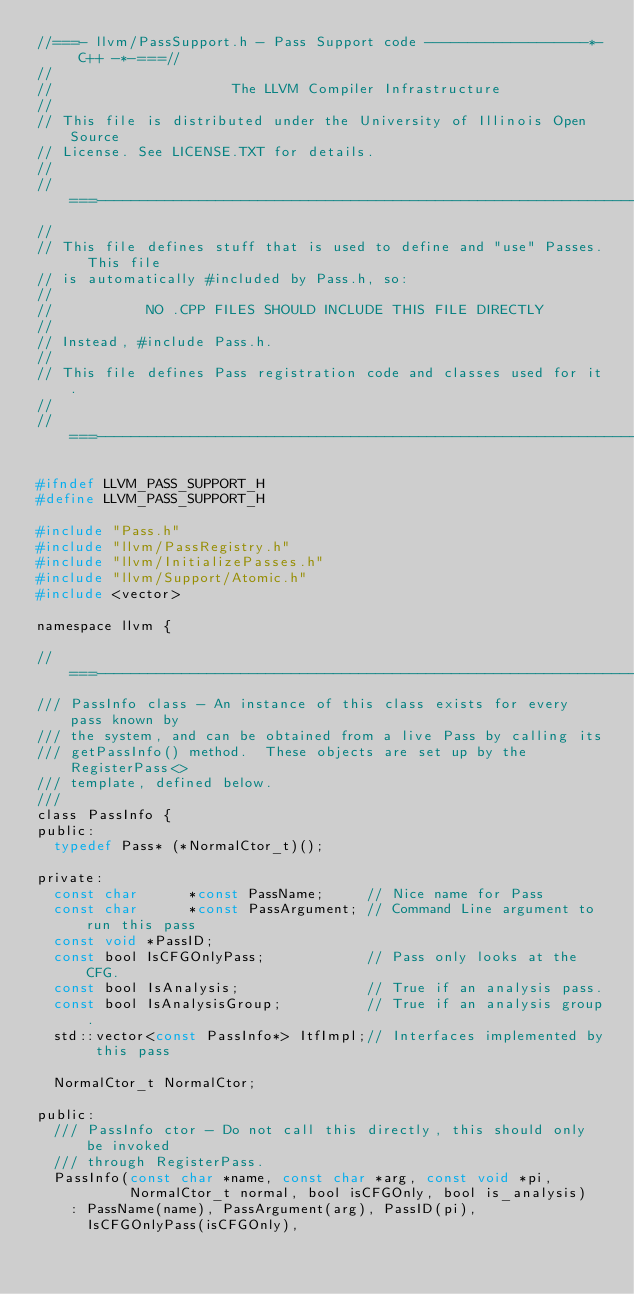Convert code to text. <code><loc_0><loc_0><loc_500><loc_500><_C_>//===- llvm/PassSupport.h - Pass Support code -------------------*- C++ -*-===//
//
//                     The LLVM Compiler Infrastructure
//
// This file is distributed under the University of Illinois Open Source
// License. See LICENSE.TXT for details.
//
//===----------------------------------------------------------------------===//
//
// This file defines stuff that is used to define and "use" Passes.  This file
// is automatically #included by Pass.h, so:
//
//           NO .CPP FILES SHOULD INCLUDE THIS FILE DIRECTLY
//
// Instead, #include Pass.h.
//
// This file defines Pass registration code and classes used for it.
//
//===----------------------------------------------------------------------===//

#ifndef LLVM_PASS_SUPPORT_H
#define LLVM_PASS_SUPPORT_H

#include "Pass.h"
#include "llvm/PassRegistry.h"
#include "llvm/InitializePasses.h"
#include "llvm/Support/Atomic.h"
#include <vector>

namespace llvm {

//===---------------------------------------------------------------------------
/// PassInfo class - An instance of this class exists for every pass known by
/// the system, and can be obtained from a live Pass by calling its
/// getPassInfo() method.  These objects are set up by the RegisterPass<>
/// template, defined below.
///
class PassInfo {
public:
  typedef Pass* (*NormalCtor_t)();

private:
  const char      *const PassName;     // Nice name for Pass
  const char      *const PassArgument; // Command Line argument to run this pass
  const void *PassID;      
  const bool IsCFGOnlyPass;            // Pass only looks at the CFG.
  const bool IsAnalysis;               // True if an analysis pass.
  const bool IsAnalysisGroup;          // True if an analysis group.
  std::vector<const PassInfo*> ItfImpl;// Interfaces implemented by this pass

  NormalCtor_t NormalCtor;

public:
  /// PassInfo ctor - Do not call this directly, this should only be invoked
  /// through RegisterPass.
  PassInfo(const char *name, const char *arg, const void *pi,
           NormalCtor_t normal, bool isCFGOnly, bool is_analysis)
    : PassName(name), PassArgument(arg), PassID(pi), 
      IsCFGOnlyPass(isCFGOnly), </code> 